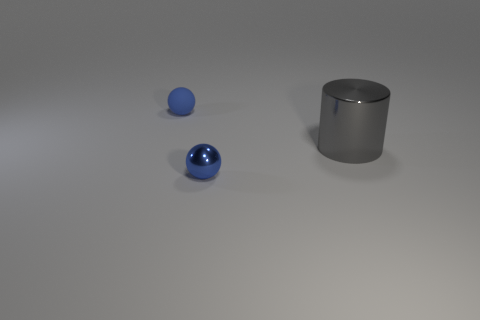What is the shape of the gray object?
Offer a very short reply. Cylinder. Is the large cylinder made of the same material as the blue thing on the right side of the tiny matte ball?
Provide a short and direct response. Yes. What number of metal things are either blue things or big gray cylinders?
Keep it short and to the point. 2. How big is the object behind the gray thing?
Provide a short and direct response. Small. The ball that is made of the same material as the gray object is what size?
Make the answer very short. Small. How many tiny matte objects are the same color as the large metallic cylinder?
Provide a short and direct response. 0. Are there any tiny rubber cylinders?
Keep it short and to the point. No. There is a large metal object; is it the same shape as the shiny thing that is in front of the cylinder?
Your answer should be compact. No. What is the color of the large shiny cylinder in front of the blue object left of the sphere in front of the large gray metallic object?
Offer a very short reply. Gray. Are there any blue balls behind the gray cylinder?
Make the answer very short. Yes. 